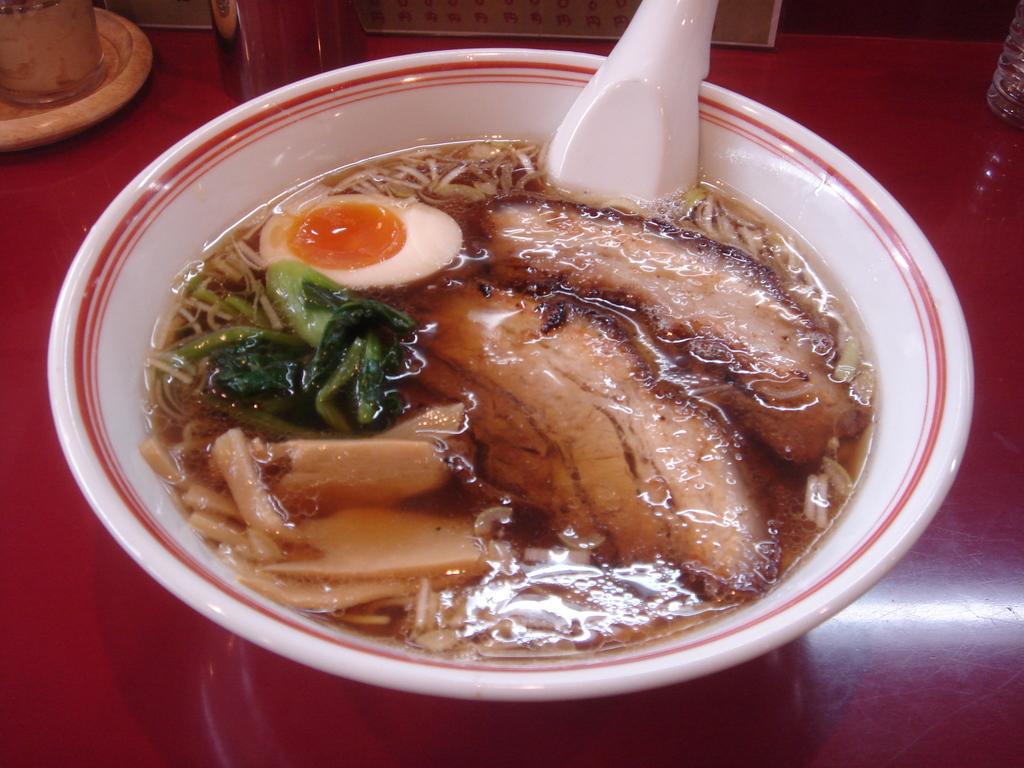Please provide a concise description of this image. On the table we can see cup, saucer and bowl. In that bowl we can see half egg, cabbage, onion pieces, bread, water and other objects. At the top there is a paper. In the top right corner there is a water bottle. 